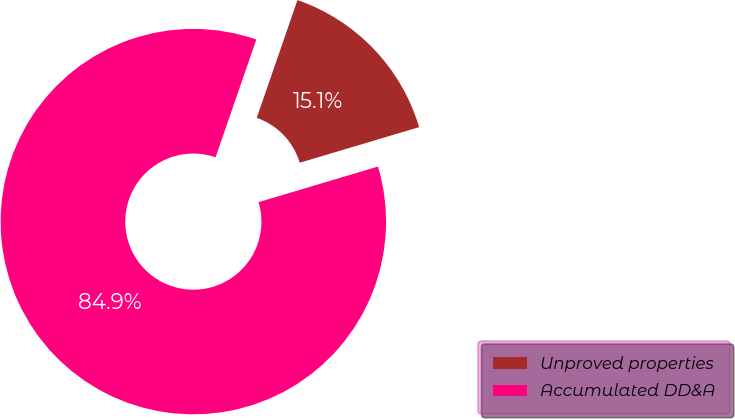Convert chart. <chart><loc_0><loc_0><loc_500><loc_500><pie_chart><fcel>Unproved properties<fcel>Accumulated DD&A<nl><fcel>15.09%<fcel>84.91%<nl></chart> 